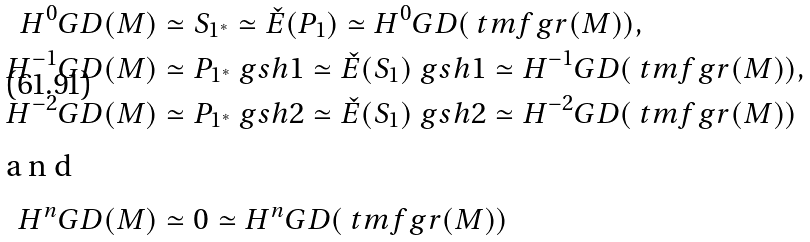<formula> <loc_0><loc_0><loc_500><loc_500>H ^ { 0 } G D ( M ) & \simeq S _ { 1 ^ { \ast } } \simeq \check { E } ( P _ { 1 } ) \simeq H ^ { 0 } G D ( \ t m f g r ( M ) ) , \\ H ^ { - 1 } G D ( M ) & \simeq P _ { 1 ^ { \ast } } \ g s h 1 \simeq \check { E } ( S _ { 1 } ) \ g s h 1 \simeq H ^ { - 1 } G D ( \ t m f g r ( M ) ) , \\ H ^ { - 2 } G D ( M ) & \simeq P _ { 1 ^ { \ast } } \ g s h 2 \simeq \check { E } ( S _ { 1 } ) \ g s h 2 \simeq H ^ { - 2 } G D ( \ t m f g r ( M ) ) \\ \intertext { a n d } H ^ { n } G D ( M ) & \simeq 0 \simeq H ^ { n } G D ( \ t m f g r ( M ) )</formula> 